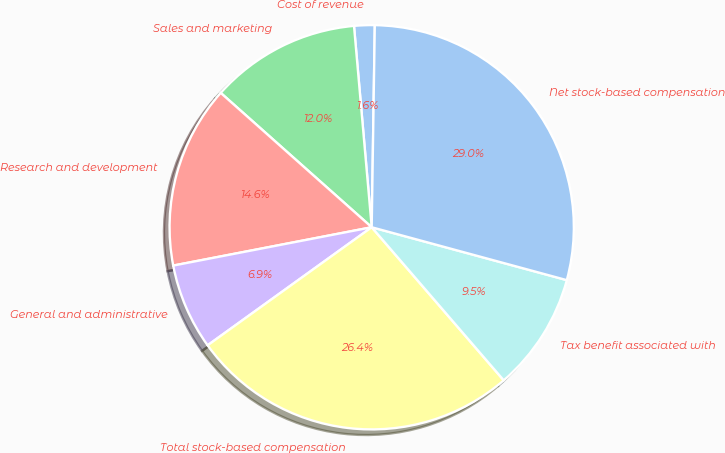Convert chart to OTSL. <chart><loc_0><loc_0><loc_500><loc_500><pie_chart><fcel>Cost of revenue<fcel>Sales and marketing<fcel>Research and development<fcel>General and administrative<fcel>Total stock-based compensation<fcel>Tax benefit associated with<fcel>Net stock-based compensation<nl><fcel>1.64%<fcel>12.03%<fcel>14.61%<fcel>6.89%<fcel>26.4%<fcel>9.46%<fcel>28.97%<nl></chart> 